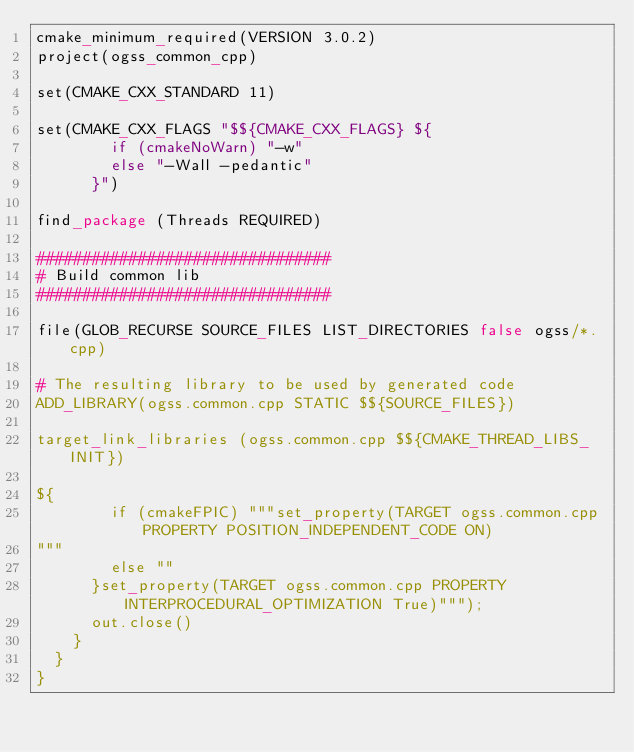<code> <loc_0><loc_0><loc_500><loc_500><_Scala_>cmake_minimum_required(VERSION 3.0.2)
project(ogss_common_cpp)

set(CMAKE_CXX_STANDARD 11)

set(CMAKE_CXX_FLAGS "$${CMAKE_CXX_FLAGS} ${
        if (cmakeNoWarn) "-w"
        else "-Wall -pedantic"
      }")

find_package (Threads REQUIRED)

################################
# Build common lib
################################

file(GLOB_RECURSE SOURCE_FILES LIST_DIRECTORIES false ogss/*.cpp)

# The resulting library to be used by generated code
ADD_LIBRARY(ogss.common.cpp STATIC $${SOURCE_FILES})

target_link_libraries (ogss.common.cpp $${CMAKE_THREAD_LIBS_INIT})

${
        if (cmakeFPIC) """set_property(TARGET ogss.common.cpp PROPERTY POSITION_INDEPENDENT_CODE ON)
"""
        else ""
      }set_property(TARGET ogss.common.cpp PROPERTY INTERPROCEDURAL_OPTIMIZATION True)""");
      out.close()
    }
  }
}
</code> 